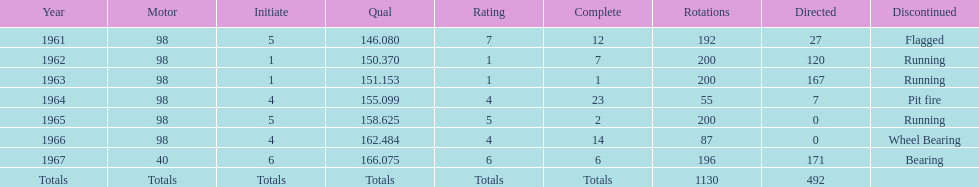What year(s) did parnelli finish at least 4th or better? 1963, 1965. 